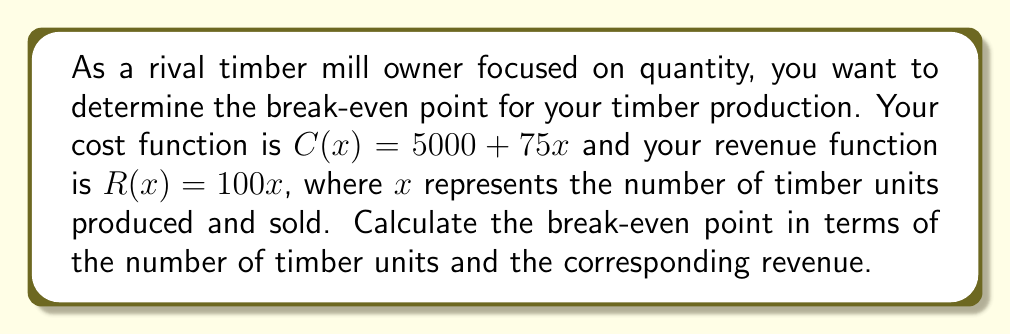Show me your answer to this math problem. To find the break-even point, we need to determine where the cost function equals the revenue function. At this point, the profit is zero.

1. Set up the equation:
   $C(x) = R(x)$
   $5000 + 75x = 100x$

2. Solve for $x$:
   $5000 + 75x = 100x$
   $5000 = 100x - 75x$
   $5000 = 25x$
   $x = 5000 \div 25 = 200$

3. Calculate the corresponding revenue:
   $R(x) = 100x$
   $R(200) = 100 \cdot 200 = 20000$

The break-even point occurs when 200 timber units are produced and sold, generating a revenue of $20,000.

To verify, we can calculate the cost at this point:
$C(200) = 5000 + 75 \cdot 200 = 5000 + 15000 = 20000$

Since the cost and revenue are equal at this point, it confirms our break-even calculation.
Answer: The break-even point occurs at 200 timber units, with a corresponding revenue of $20,000. 